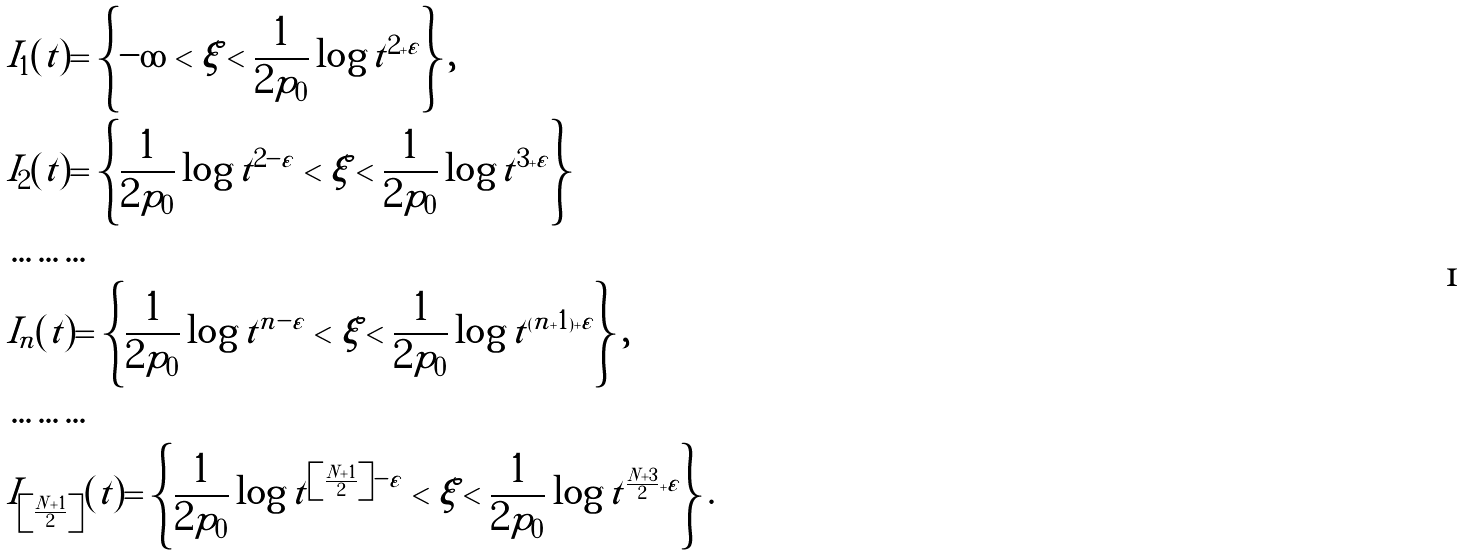Convert formula to latex. <formula><loc_0><loc_0><loc_500><loc_500>& I _ { 1 } ( t ) = \left \{ - \infty < \xi < \frac { 1 } { 2 p _ { 0 } } \log t ^ { 2 + \varepsilon } \right \} , \\ & I _ { 2 } ( t ) = \left \{ \frac { 1 } { 2 p _ { 0 } } \log t ^ { 2 - \varepsilon } < \xi < \frac { 1 } { 2 p _ { 0 } } \log t ^ { 3 + \varepsilon } \right \} \\ & \dots \dots \dots \\ & I _ { n } ( t ) = \left \{ \frac { 1 } { 2 p _ { 0 } } \log t ^ { n - \varepsilon } < \xi < \frac { 1 } { 2 p _ { 0 } } \log t ^ { ( n + 1 ) + \varepsilon } \right \} , \\ & \dots \dots \dots \\ & I _ { \left [ \frac { N + 1 } { 2 } \right ] } ( t ) = \left \{ \frac { 1 } { 2 p _ { 0 } } \log t ^ { \left [ \frac { N + 1 } { 2 } \right ] - \varepsilon } < \xi < \frac { 1 } { 2 p _ { 0 } } \log t ^ { \frac { N + 3 } { 2 } + \varepsilon } \right \} .</formula> 